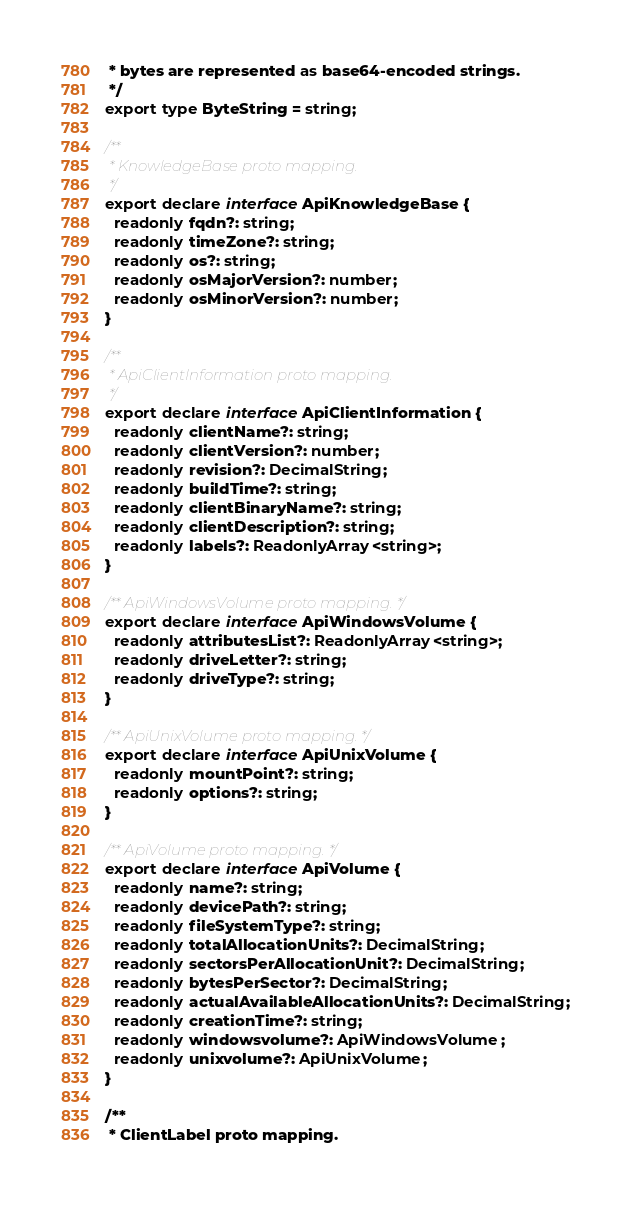Convert code to text. <code><loc_0><loc_0><loc_500><loc_500><_TypeScript_> * bytes are represented as base64-encoded strings.
 */
export type ByteString = string;

/**
 * KnowledgeBase proto mapping.
 */
export declare interface ApiKnowledgeBase {
  readonly fqdn?: string;
  readonly timeZone?: string;
  readonly os?: string;
  readonly osMajorVersion?: number;
  readonly osMinorVersion?: number;
}

/**
 * ApiClientInformation proto mapping.
 */
export declare interface ApiClientInformation {
  readonly clientName?: string;
  readonly clientVersion?: number;
  readonly revision?: DecimalString;
  readonly buildTime?: string;
  readonly clientBinaryName?: string;
  readonly clientDescription?: string;
  readonly labels?: ReadonlyArray<string>;
}

/** ApiWindowsVolume proto mapping. */
export declare interface ApiWindowsVolume {
  readonly attributesList?: ReadonlyArray<string>;
  readonly driveLetter?: string;
  readonly driveType?: string;
}

/** ApiUnixVolume proto mapping. */
export declare interface ApiUnixVolume {
  readonly mountPoint?: string;
  readonly options?: string;
}

/** ApiVolume proto mapping. */
export declare interface ApiVolume {
  readonly name?: string;
  readonly devicePath?: string;
  readonly fileSystemType?: string;
  readonly totalAllocationUnits?: DecimalString;
  readonly sectorsPerAllocationUnit?: DecimalString;
  readonly bytesPerSector?: DecimalString;
  readonly actualAvailableAllocationUnits?: DecimalString;
  readonly creationTime?: string;
  readonly windowsvolume?: ApiWindowsVolume;
  readonly unixvolume?: ApiUnixVolume;
}

/**
 * ClientLabel proto mapping.</code> 